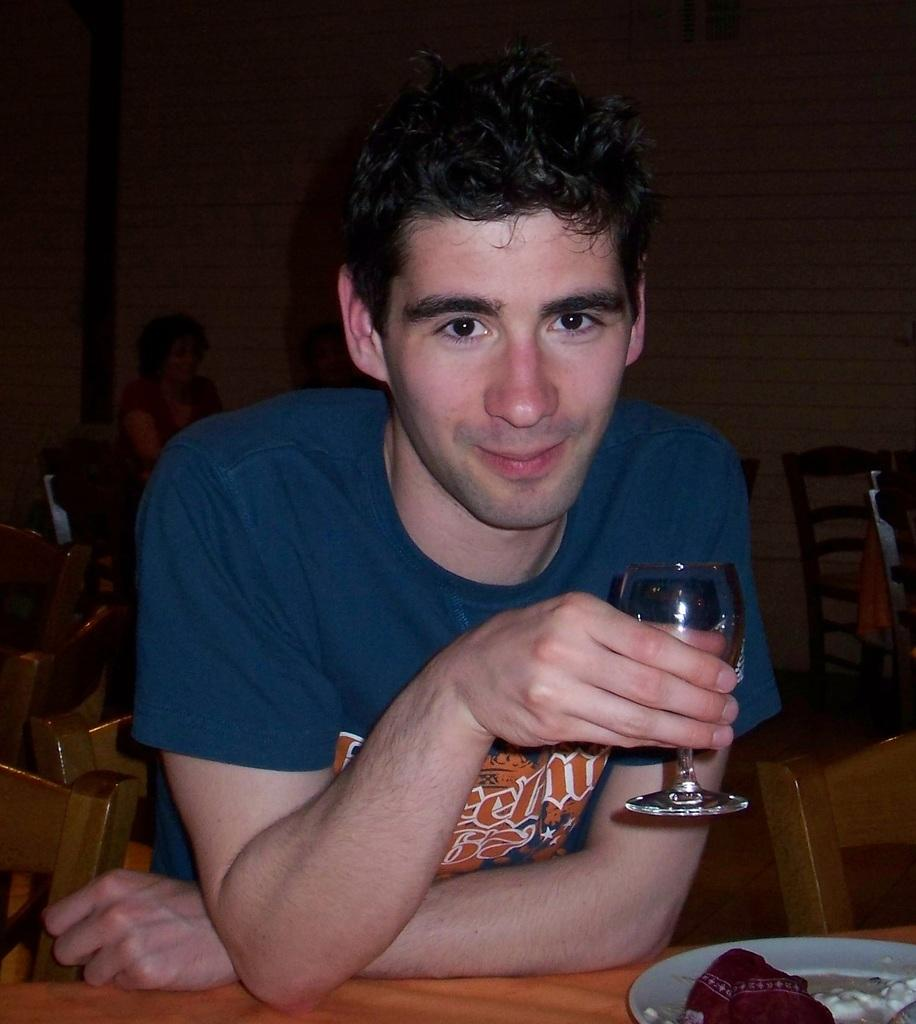Who is present in the image? There is a man in the image. What is the man doing in the image? The man is sitting at a table. What is the man holding in his right hand? The man is holding a wine glass in his right hand. What type of tree can be seen growing in the wine glass in the image? There is no tree growing in the wine glass in the image; it contains a liquid, presumably wine. How many tomatoes are on the table in the image? There is no mention of tomatoes in the image, so it cannot be determined how many are present. 